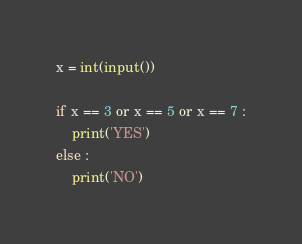Convert code to text. <code><loc_0><loc_0><loc_500><loc_500><_Python_>x = int(input())

if x == 3 or x == 5 or x == 7 :
    print('YES')
else :
    print('NO')</code> 